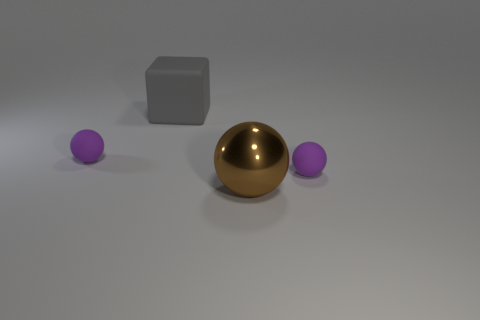Are there any brown balls that have the same size as the gray block? yes 